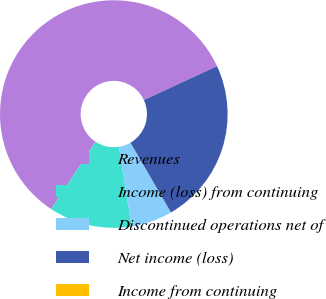Convert chart to OTSL. <chart><loc_0><loc_0><loc_500><loc_500><pie_chart><fcel>Revenues<fcel>Income (loss) from continuing<fcel>Discontinued operations net of<fcel>Net income (loss)<fcel>Income from continuing<nl><fcel>58.82%<fcel>11.76%<fcel>5.88%<fcel>23.53%<fcel>0.0%<nl></chart> 